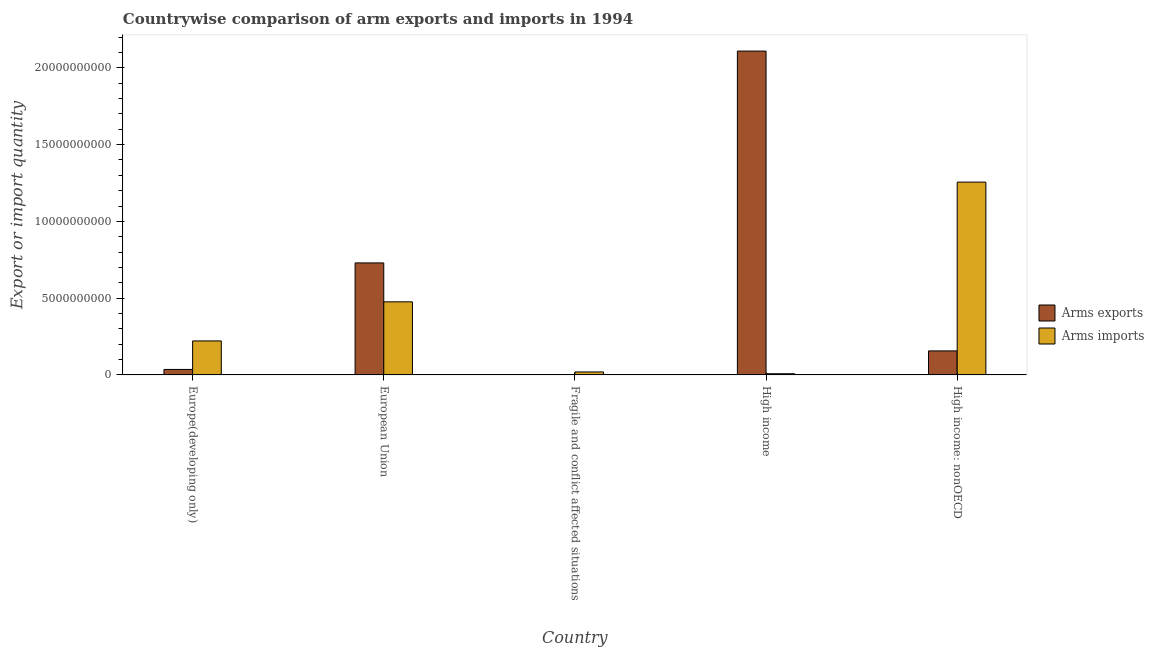Are the number of bars on each tick of the X-axis equal?
Make the answer very short. Yes. How many bars are there on the 5th tick from the left?
Keep it short and to the point. 2. How many bars are there on the 3rd tick from the right?
Provide a short and direct response. 2. What is the label of the 3rd group of bars from the left?
Give a very brief answer. Fragile and conflict affected situations. In how many cases, is the number of bars for a given country not equal to the number of legend labels?
Provide a succinct answer. 0. What is the arms imports in High income?
Your answer should be compact. 7.60e+07. Across all countries, what is the maximum arms exports?
Your response must be concise. 2.11e+1. Across all countries, what is the minimum arms exports?
Provide a succinct answer. 3.00e+06. In which country was the arms exports maximum?
Your answer should be compact. High income. In which country was the arms imports minimum?
Your answer should be compact. High income. What is the total arms imports in the graph?
Your response must be concise. 1.98e+1. What is the difference between the arms exports in European Union and that in High income: nonOECD?
Offer a terse response. 5.73e+09. What is the difference between the arms exports in European Union and the arms imports in High income?
Offer a very short reply. 7.22e+09. What is the average arms imports per country?
Make the answer very short. 3.96e+09. What is the difference between the arms exports and arms imports in European Union?
Your answer should be compact. 2.54e+09. What is the ratio of the arms imports in European Union to that in Fragile and conflict affected situations?
Ensure brevity in your answer.  24.66. What is the difference between the highest and the second highest arms exports?
Offer a terse response. 1.38e+1. What is the difference between the highest and the lowest arms exports?
Keep it short and to the point. 2.11e+1. In how many countries, is the arms exports greater than the average arms exports taken over all countries?
Make the answer very short. 2. What does the 1st bar from the left in European Union represents?
Offer a terse response. Arms exports. What does the 2nd bar from the right in Europe(developing only) represents?
Provide a short and direct response. Arms exports. How many bars are there?
Keep it short and to the point. 10. How many countries are there in the graph?
Provide a short and direct response. 5. What is the difference between two consecutive major ticks on the Y-axis?
Offer a terse response. 5.00e+09. Are the values on the major ticks of Y-axis written in scientific E-notation?
Keep it short and to the point. No. Does the graph contain any zero values?
Offer a very short reply. No. Does the graph contain grids?
Ensure brevity in your answer.  No. How many legend labels are there?
Your answer should be compact. 2. What is the title of the graph?
Provide a short and direct response. Countrywise comparison of arm exports and imports in 1994. What is the label or title of the X-axis?
Give a very brief answer. Country. What is the label or title of the Y-axis?
Your response must be concise. Export or import quantity. What is the Export or import quantity in Arms exports in Europe(developing only)?
Your answer should be compact. 3.56e+08. What is the Export or import quantity of Arms imports in Europe(developing only)?
Keep it short and to the point. 2.21e+09. What is the Export or import quantity of Arms exports in European Union?
Your answer should be compact. 7.30e+09. What is the Export or import quantity of Arms imports in European Union?
Give a very brief answer. 4.76e+09. What is the Export or import quantity in Arms imports in Fragile and conflict affected situations?
Your answer should be compact. 1.93e+08. What is the Export or import quantity of Arms exports in High income?
Keep it short and to the point. 2.11e+1. What is the Export or import quantity in Arms imports in High income?
Provide a short and direct response. 7.60e+07. What is the Export or import quantity in Arms exports in High income: nonOECD?
Provide a short and direct response. 1.56e+09. What is the Export or import quantity in Arms imports in High income: nonOECD?
Keep it short and to the point. 1.26e+1. Across all countries, what is the maximum Export or import quantity in Arms exports?
Give a very brief answer. 2.11e+1. Across all countries, what is the maximum Export or import quantity of Arms imports?
Keep it short and to the point. 1.26e+1. Across all countries, what is the minimum Export or import quantity of Arms imports?
Offer a very short reply. 7.60e+07. What is the total Export or import quantity of Arms exports in the graph?
Provide a succinct answer. 3.03e+1. What is the total Export or import quantity in Arms imports in the graph?
Offer a terse response. 1.98e+1. What is the difference between the Export or import quantity in Arms exports in Europe(developing only) and that in European Union?
Ensure brevity in your answer.  -6.94e+09. What is the difference between the Export or import quantity in Arms imports in Europe(developing only) and that in European Union?
Offer a very short reply. -2.55e+09. What is the difference between the Export or import quantity of Arms exports in Europe(developing only) and that in Fragile and conflict affected situations?
Provide a short and direct response. 3.53e+08. What is the difference between the Export or import quantity in Arms imports in Europe(developing only) and that in Fragile and conflict affected situations?
Keep it short and to the point. 2.02e+09. What is the difference between the Export or import quantity of Arms exports in Europe(developing only) and that in High income?
Give a very brief answer. -2.07e+1. What is the difference between the Export or import quantity of Arms imports in Europe(developing only) and that in High income?
Ensure brevity in your answer.  2.14e+09. What is the difference between the Export or import quantity in Arms exports in Europe(developing only) and that in High income: nonOECD?
Your response must be concise. -1.21e+09. What is the difference between the Export or import quantity of Arms imports in Europe(developing only) and that in High income: nonOECD?
Your answer should be very brief. -1.03e+1. What is the difference between the Export or import quantity of Arms exports in European Union and that in Fragile and conflict affected situations?
Provide a succinct answer. 7.29e+09. What is the difference between the Export or import quantity in Arms imports in European Union and that in Fragile and conflict affected situations?
Give a very brief answer. 4.57e+09. What is the difference between the Export or import quantity of Arms exports in European Union and that in High income?
Your answer should be very brief. -1.38e+1. What is the difference between the Export or import quantity in Arms imports in European Union and that in High income?
Your answer should be compact. 4.68e+09. What is the difference between the Export or import quantity in Arms exports in European Union and that in High income: nonOECD?
Offer a terse response. 5.73e+09. What is the difference between the Export or import quantity of Arms imports in European Union and that in High income: nonOECD?
Your answer should be very brief. -7.80e+09. What is the difference between the Export or import quantity of Arms exports in Fragile and conflict affected situations and that in High income?
Make the answer very short. -2.11e+1. What is the difference between the Export or import quantity of Arms imports in Fragile and conflict affected situations and that in High income?
Keep it short and to the point. 1.17e+08. What is the difference between the Export or import quantity in Arms exports in Fragile and conflict affected situations and that in High income: nonOECD?
Offer a very short reply. -1.56e+09. What is the difference between the Export or import quantity of Arms imports in Fragile and conflict affected situations and that in High income: nonOECD?
Ensure brevity in your answer.  -1.24e+1. What is the difference between the Export or import quantity in Arms exports in High income and that in High income: nonOECD?
Your response must be concise. 1.95e+1. What is the difference between the Export or import quantity in Arms imports in High income and that in High income: nonOECD?
Your response must be concise. -1.25e+1. What is the difference between the Export or import quantity in Arms exports in Europe(developing only) and the Export or import quantity in Arms imports in European Union?
Keep it short and to the point. -4.40e+09. What is the difference between the Export or import quantity of Arms exports in Europe(developing only) and the Export or import quantity of Arms imports in Fragile and conflict affected situations?
Make the answer very short. 1.63e+08. What is the difference between the Export or import quantity in Arms exports in Europe(developing only) and the Export or import quantity in Arms imports in High income?
Make the answer very short. 2.80e+08. What is the difference between the Export or import quantity of Arms exports in Europe(developing only) and the Export or import quantity of Arms imports in High income: nonOECD?
Offer a terse response. -1.22e+1. What is the difference between the Export or import quantity in Arms exports in European Union and the Export or import quantity in Arms imports in Fragile and conflict affected situations?
Make the answer very short. 7.10e+09. What is the difference between the Export or import quantity in Arms exports in European Union and the Export or import quantity in Arms imports in High income?
Your answer should be very brief. 7.22e+09. What is the difference between the Export or import quantity of Arms exports in European Union and the Export or import quantity of Arms imports in High income: nonOECD?
Your answer should be very brief. -5.26e+09. What is the difference between the Export or import quantity in Arms exports in Fragile and conflict affected situations and the Export or import quantity in Arms imports in High income?
Keep it short and to the point. -7.30e+07. What is the difference between the Export or import quantity of Arms exports in Fragile and conflict affected situations and the Export or import quantity of Arms imports in High income: nonOECD?
Provide a short and direct response. -1.26e+1. What is the difference between the Export or import quantity in Arms exports in High income and the Export or import quantity in Arms imports in High income: nonOECD?
Keep it short and to the point. 8.54e+09. What is the average Export or import quantity in Arms exports per country?
Provide a short and direct response. 6.06e+09. What is the average Export or import quantity in Arms imports per country?
Offer a very short reply. 3.96e+09. What is the difference between the Export or import quantity of Arms exports and Export or import quantity of Arms imports in Europe(developing only)?
Make the answer very short. -1.86e+09. What is the difference between the Export or import quantity of Arms exports and Export or import quantity of Arms imports in European Union?
Make the answer very short. 2.54e+09. What is the difference between the Export or import quantity in Arms exports and Export or import quantity in Arms imports in Fragile and conflict affected situations?
Your response must be concise. -1.90e+08. What is the difference between the Export or import quantity in Arms exports and Export or import quantity in Arms imports in High income?
Make the answer very short. 2.10e+1. What is the difference between the Export or import quantity of Arms exports and Export or import quantity of Arms imports in High income: nonOECD?
Offer a terse response. -1.10e+1. What is the ratio of the Export or import quantity of Arms exports in Europe(developing only) to that in European Union?
Offer a very short reply. 0.05. What is the ratio of the Export or import quantity of Arms imports in Europe(developing only) to that in European Union?
Give a very brief answer. 0.47. What is the ratio of the Export or import quantity in Arms exports in Europe(developing only) to that in Fragile and conflict affected situations?
Give a very brief answer. 118.67. What is the ratio of the Export or import quantity in Arms imports in Europe(developing only) to that in Fragile and conflict affected situations?
Your answer should be compact. 11.47. What is the ratio of the Export or import quantity of Arms exports in Europe(developing only) to that in High income?
Give a very brief answer. 0.02. What is the ratio of the Export or import quantity of Arms imports in Europe(developing only) to that in High income?
Ensure brevity in your answer.  29.13. What is the ratio of the Export or import quantity in Arms exports in Europe(developing only) to that in High income: nonOECD?
Give a very brief answer. 0.23. What is the ratio of the Export or import quantity in Arms imports in Europe(developing only) to that in High income: nonOECD?
Provide a succinct answer. 0.18. What is the ratio of the Export or import quantity in Arms exports in European Union to that in Fragile and conflict affected situations?
Your answer should be very brief. 2432. What is the ratio of the Export or import quantity in Arms imports in European Union to that in Fragile and conflict affected situations?
Your answer should be very brief. 24.66. What is the ratio of the Export or import quantity in Arms exports in European Union to that in High income?
Keep it short and to the point. 0.35. What is the ratio of the Export or import quantity of Arms imports in European Union to that in High income?
Make the answer very short. 62.63. What is the ratio of the Export or import quantity in Arms exports in European Union to that in High income: nonOECD?
Keep it short and to the point. 4.67. What is the ratio of the Export or import quantity in Arms imports in European Union to that in High income: nonOECD?
Provide a succinct answer. 0.38. What is the ratio of the Export or import quantity of Arms exports in Fragile and conflict affected situations to that in High income?
Provide a short and direct response. 0. What is the ratio of the Export or import quantity in Arms imports in Fragile and conflict affected situations to that in High income?
Give a very brief answer. 2.54. What is the ratio of the Export or import quantity of Arms exports in Fragile and conflict affected situations to that in High income: nonOECD?
Your response must be concise. 0. What is the ratio of the Export or import quantity of Arms imports in Fragile and conflict affected situations to that in High income: nonOECD?
Your response must be concise. 0.02. What is the ratio of the Export or import quantity of Arms exports in High income to that in High income: nonOECD?
Offer a terse response. 13.49. What is the ratio of the Export or import quantity in Arms imports in High income to that in High income: nonOECD?
Give a very brief answer. 0.01. What is the difference between the highest and the second highest Export or import quantity of Arms exports?
Ensure brevity in your answer.  1.38e+1. What is the difference between the highest and the second highest Export or import quantity of Arms imports?
Your answer should be compact. 7.80e+09. What is the difference between the highest and the lowest Export or import quantity of Arms exports?
Make the answer very short. 2.11e+1. What is the difference between the highest and the lowest Export or import quantity in Arms imports?
Your response must be concise. 1.25e+1. 